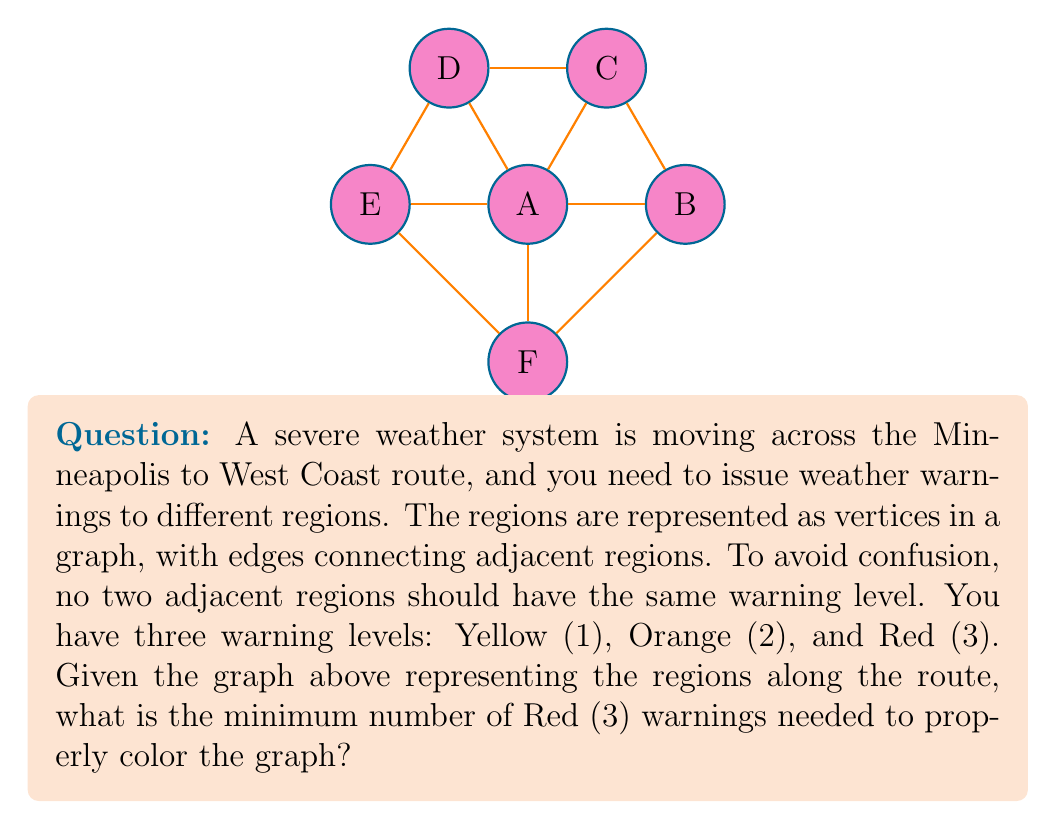Can you answer this question? To solve this problem, we need to apply graph coloring techniques:

1) First, observe that the graph is a wheel graph with 6 vertices (W_6). The central vertex (A) is connected to all other vertices.

2) In graph coloring, the chromatic number χ(G) is the minimum number of colors needed to color the vertices such that no two adjacent vertices have the same color.

3) For a wheel graph W_n:
   - If n is odd, χ(W_n) = 4
   - If n is even, χ(W_n) = 3

4) In our case, n = 6 (even), so χ(W_6) = 3. This means we need at least 3 colors to properly color the graph.

5) Given that we have three warning levels (Yellow (1), Orange (2), and Red (3)), we can use these as our three colors.

6) To minimize the number of Red (3) warnings, we should try to use Yellow (1) and Orange (2) as much as possible.

7) One optimal coloring would be:
   - Vertex A: Red (3)
   - Vertices B, D, F: Yellow (1)
   - Vertices C, E: Orange (2)

8) In this coloring, we only use Red (3) once, which is the minimum possible.

Therefore, the minimum number of Red (3) warnings needed is 1.
Answer: 1 